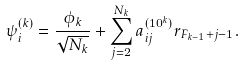<formula> <loc_0><loc_0><loc_500><loc_500>\psi _ { i } ^ { ( k ) } = \frac { \phi _ { k } } { \sqrt { N _ { k } } } + \sum _ { j = 2 } ^ { N _ { k } } a _ { i j } ^ { ( 1 0 ^ { k } ) } r _ { F _ { k - 1 } + j - 1 } .</formula> 